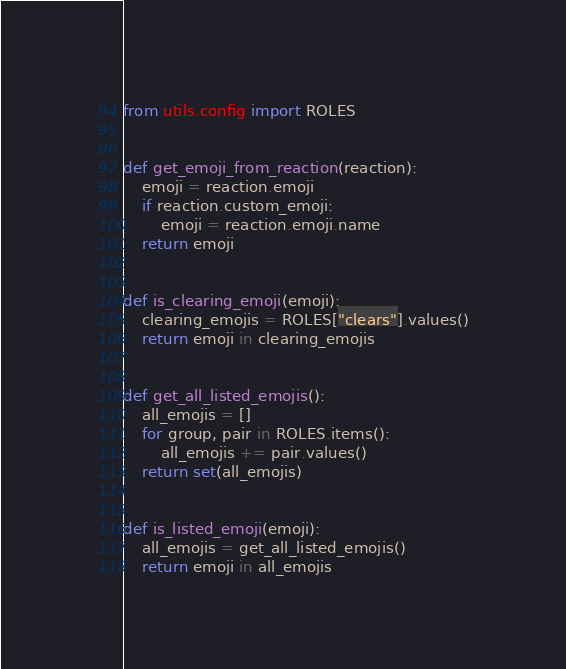Convert code to text. <code><loc_0><loc_0><loc_500><loc_500><_Python_>from utils.config import ROLES


def get_emoji_from_reaction(reaction):
    emoji = reaction.emoji
    if reaction.custom_emoji:
        emoji = reaction.emoji.name
    return emoji


def is_clearing_emoji(emoji):
    clearing_emojis = ROLES["clears"].values()
    return emoji in clearing_emojis


def get_all_listed_emojis():
    all_emojis = []
    for group, pair in ROLES.items():
        all_emojis += pair.values()
    return set(all_emojis)


def is_listed_emoji(emoji):
    all_emojis = get_all_listed_emojis()
    return emoji in all_emojis
</code> 